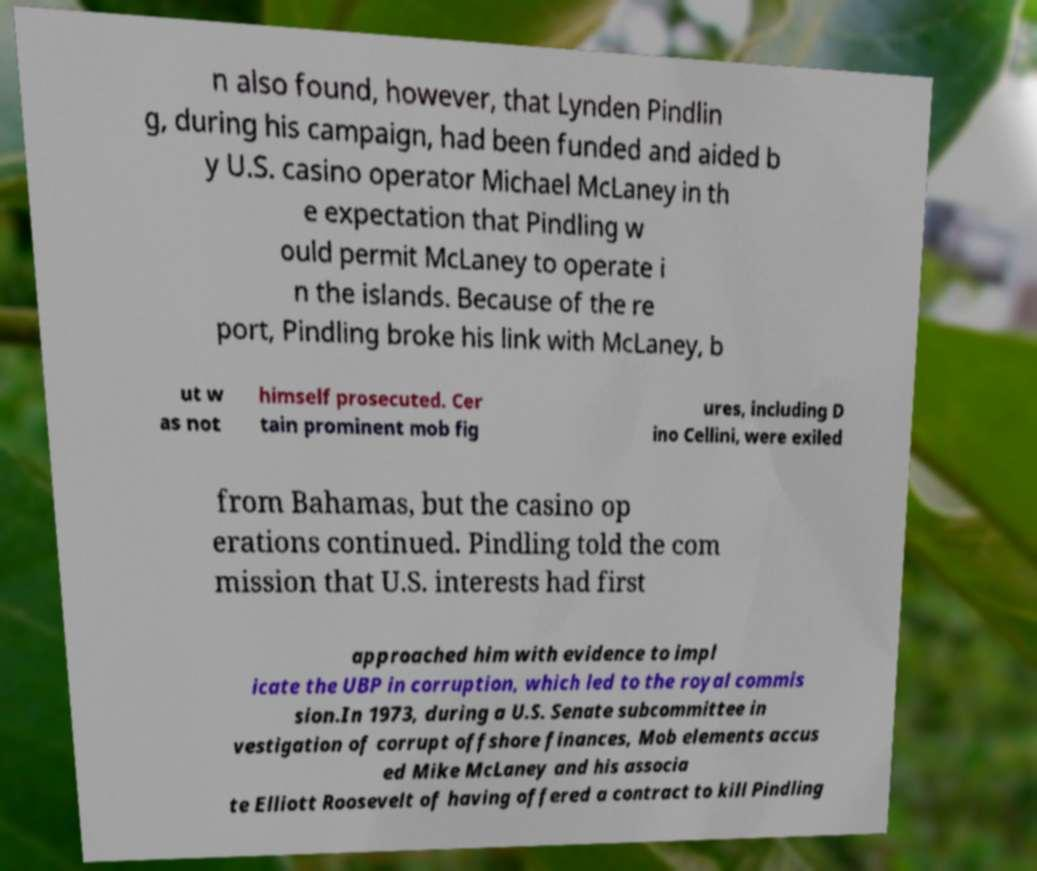I need the written content from this picture converted into text. Can you do that? n also found, however, that Lynden Pindlin g, during his campaign, had been funded and aided b y U.S. casino operator Michael McLaney in th e expectation that Pindling w ould permit McLaney to operate i n the islands. Because of the re port, Pindling broke his link with McLaney, b ut w as not himself prosecuted. Cer tain prominent mob fig ures, including D ino Cellini, were exiled from Bahamas, but the casino op erations continued. Pindling told the com mission that U.S. interests had first approached him with evidence to impl icate the UBP in corruption, which led to the royal commis sion.In 1973, during a U.S. Senate subcommittee in vestigation of corrupt offshore finances, Mob elements accus ed Mike McLaney and his associa te Elliott Roosevelt of having offered a contract to kill Pindling 